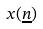<formula> <loc_0><loc_0><loc_500><loc_500>x ( \underline { n } )</formula> 